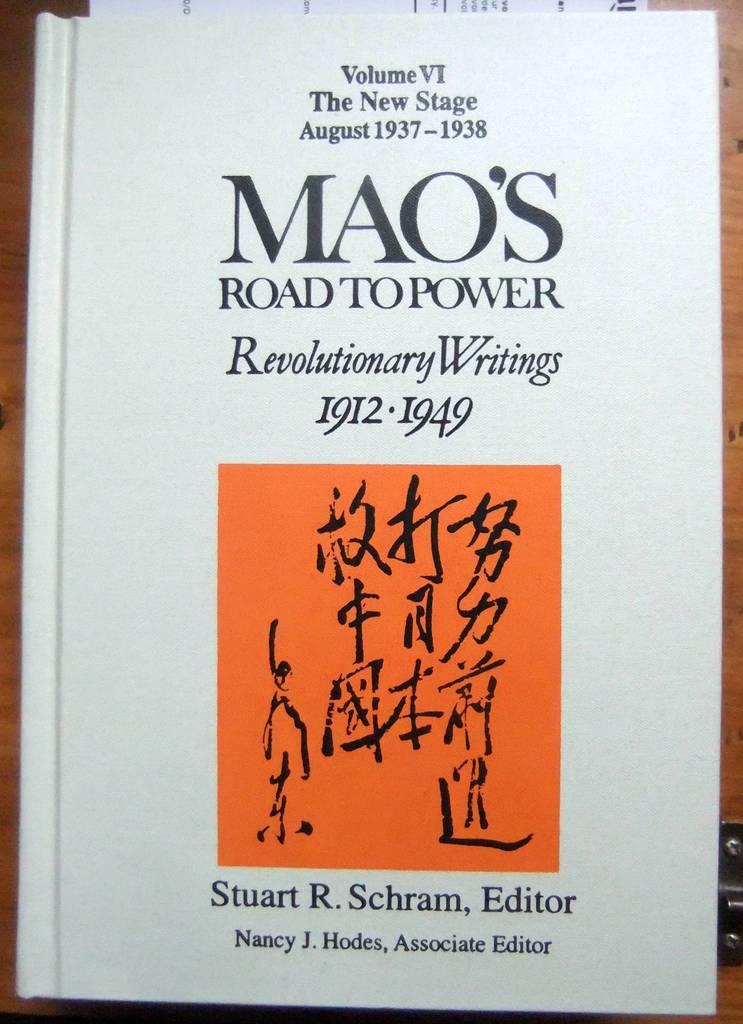What year is this book written about?
Keep it short and to the point. 1912-1949. 